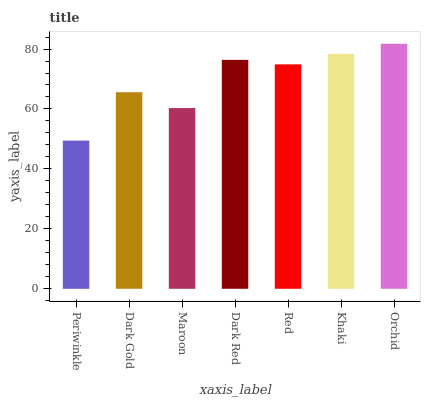Is Periwinkle the minimum?
Answer yes or no. Yes. Is Orchid the maximum?
Answer yes or no. Yes. Is Dark Gold the minimum?
Answer yes or no. No. Is Dark Gold the maximum?
Answer yes or no. No. Is Dark Gold greater than Periwinkle?
Answer yes or no. Yes. Is Periwinkle less than Dark Gold?
Answer yes or no. Yes. Is Periwinkle greater than Dark Gold?
Answer yes or no. No. Is Dark Gold less than Periwinkle?
Answer yes or no. No. Is Red the high median?
Answer yes or no. Yes. Is Red the low median?
Answer yes or no. Yes. Is Periwinkle the high median?
Answer yes or no. No. Is Maroon the low median?
Answer yes or no. No. 